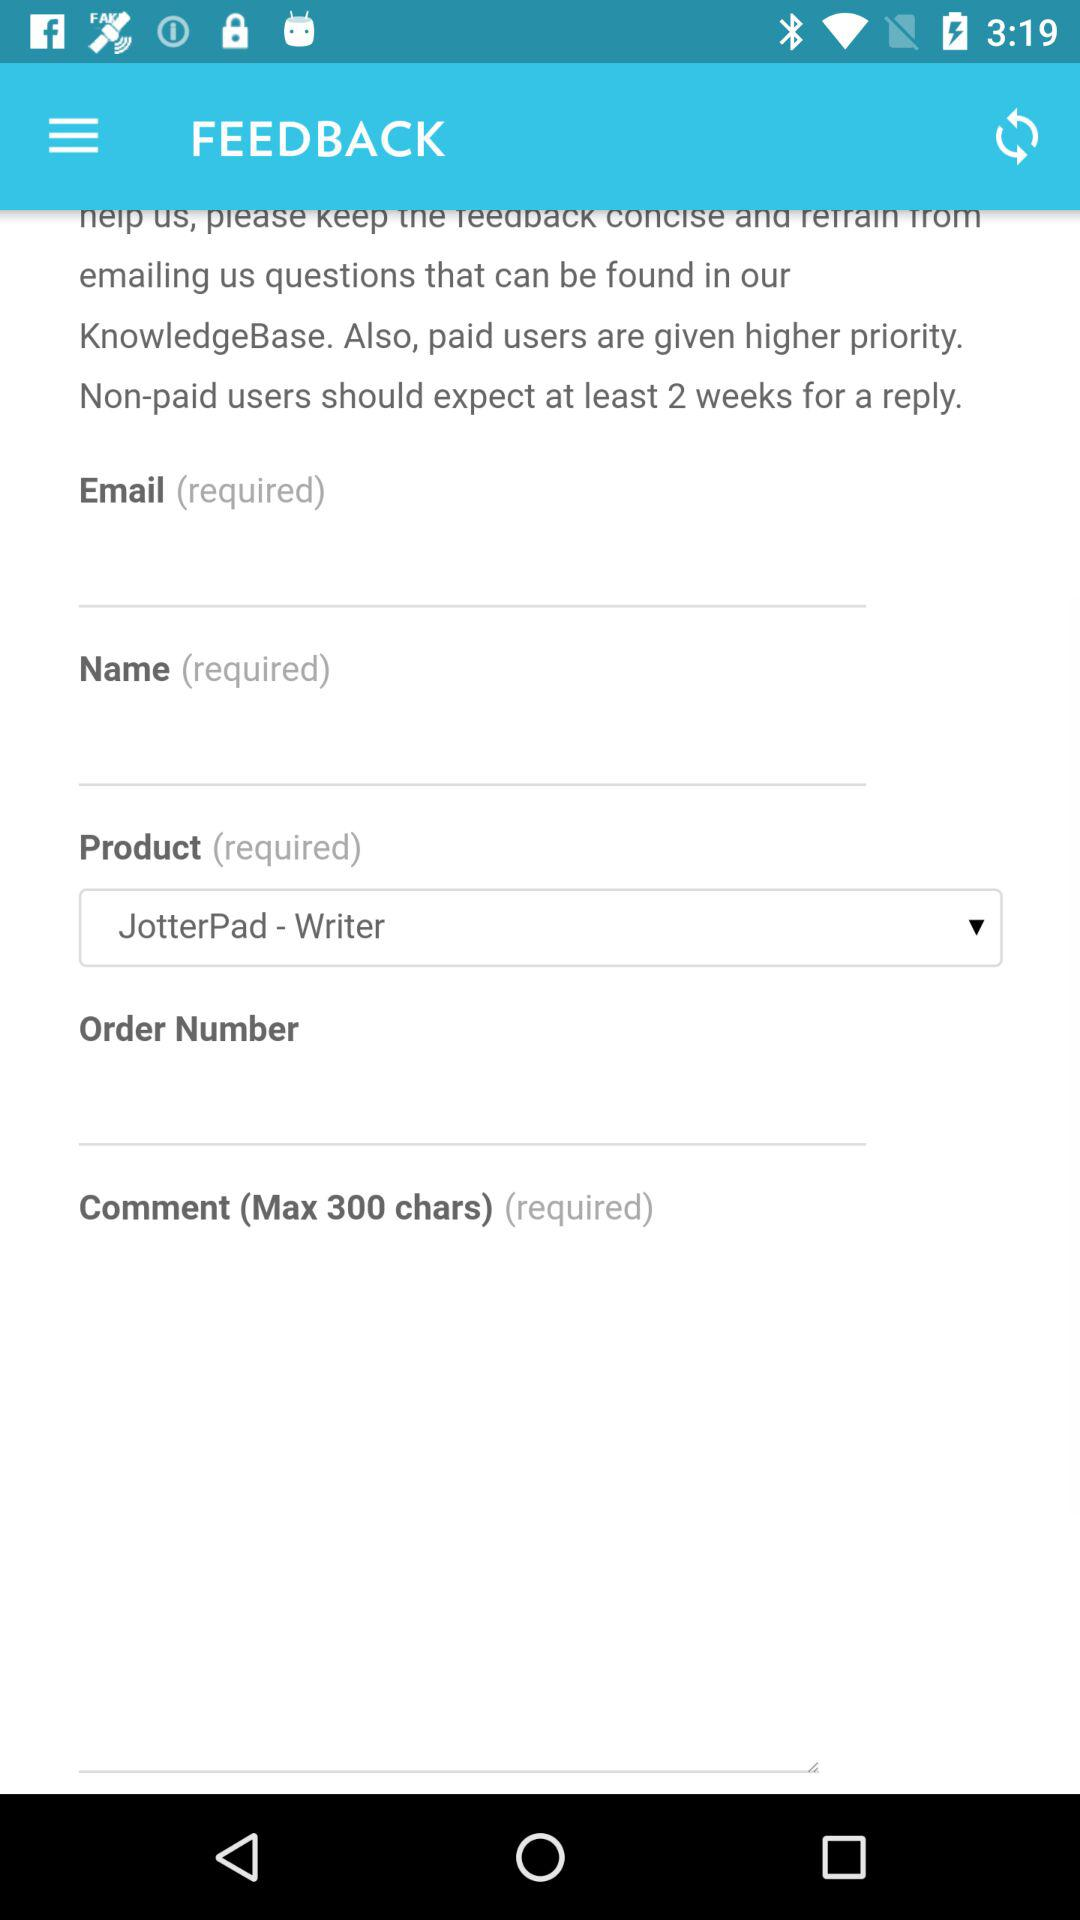What option is selected for "Product"? The selected option is "JotterPad - Writer". 